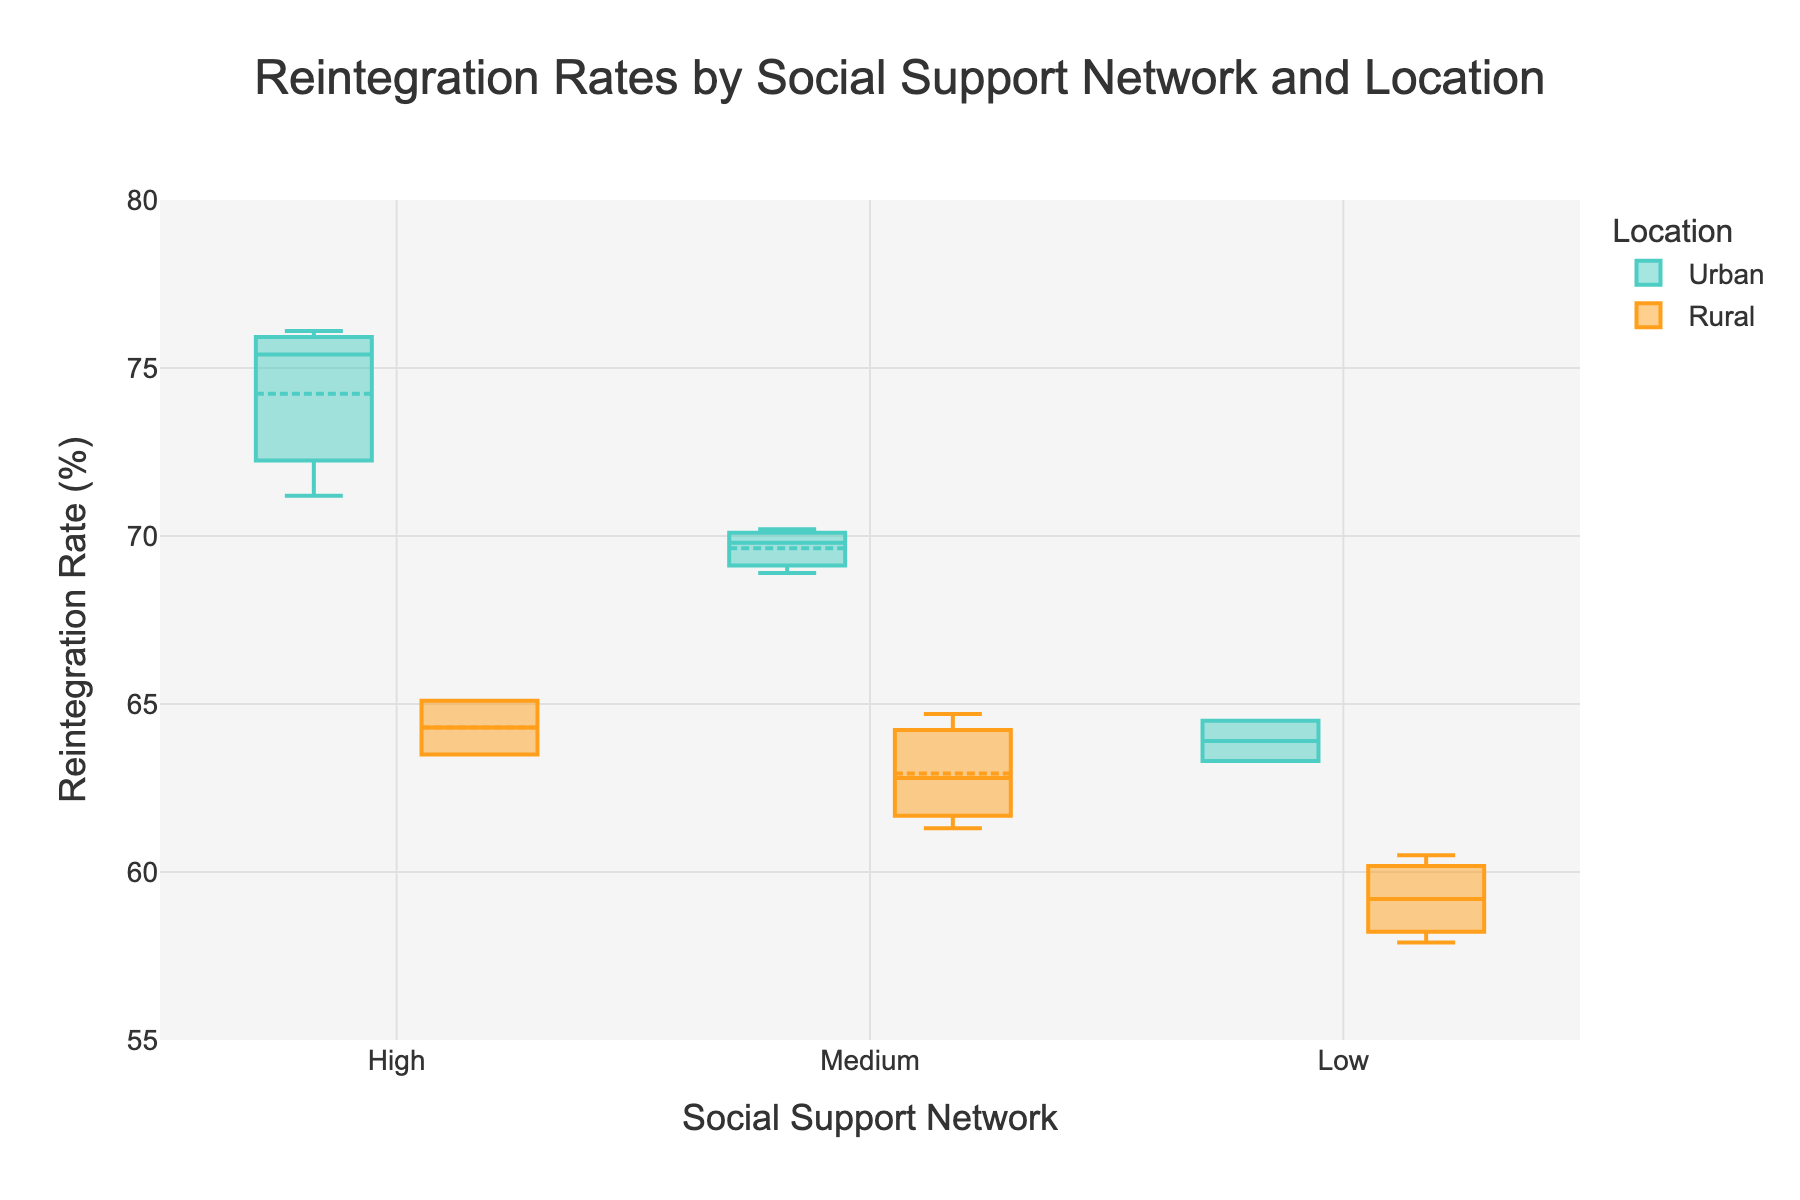How many social support network categories are there? The x-axis of the plot shows different categories of social support networks. By counting the distinct categories shown along the x-axis, we see three categories: High, Medium, and Low.
Answer: 3 What is the title of the plot? The title can be found at the top of the plot, which clearly describes what the plot is about. From the plot, the title is "Reintegration Rates by Social Support Network and Location".
Answer: Reintegration Rates by Social Support Network and Location Which location has a higher median reintegration rate for the High social support network? Look at the median lines (usually the central line within the box) for the High social support network for both Urban and Rural boxes. The Urban box for the High social support network is higher than the Rural one.
Answer: Urban What is the range of reintegration rates for the Urban group in the Medium social support network? Observe the box corresponding to the Medium social support network for the Urban group. The bottom and top edges of the box represent the interquartile range (IQR), and the whiskers indicate the full range of the data, including any outlier points.
Answer: Approximately 64 to 71 (based on visual inspection) Between Urban and Rural settings, which one shows a wider interquartile range for the Low social support network? Examine the length of the boxes for the Low social support network. The interquartile range (IQR) is represented by the height of each box. The Urban box for the Low social support network appears shorter than the Rural one, indicating a narrower IQR.
Answer: Rural Does the Urban setting show more variability in reintegration rates than the Rural setting for any social support network categories? Compare the length of the boxes (representing IQR) and the lengths of the whiskers for each category of social support network between Urban and Rural. Look for higher overall variability in one of the settings for any category.
Answer: Yes, the Urban setting shows more variability than Rural in Medium and High categories For which social support network category is the difference between Urban and Rural median reintegration rates the largest? Check the median lines (central line within each box) across all categories of social support networks. Compare the median lines of both Urban and Rural settings for each category to find the category with the largest difference.
Answer: High What is the highest reintegration rate observed across all categories and settings? Search for the highest point or the maximum value of the whiskers across all categories and settings. In this case, the whisker reaches the highest in Urban with a High social support network.
Answer: 76.1 Are there any visible outliers in the data? Look for data points that fall outside the whiskers of the box plots. In this figure, there don't appear to be any points that fall outside the typical range covered by whiskers.
Answer: No What pattern can be observed in the relation between social support network strength and reintegration rates across urban and rural settings? By comparing the trends across each social support network category for both settings, observe if stronger social support corresponds to higher reintegration rates. Generally, higher social support networks tend to show higher reintegration rates for both Urban and Rural settings.
Answer: Stronger social support generally corresponds to higher reintegration rates 